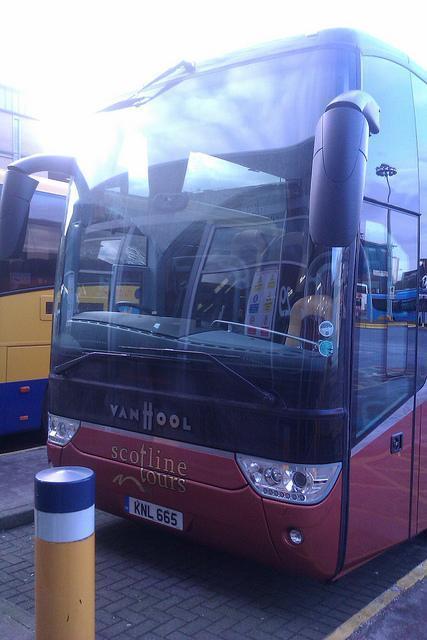How many buses are in the photo?
Give a very brief answer. 2. How many of the three people in front are wearing helmets?
Give a very brief answer. 0. 